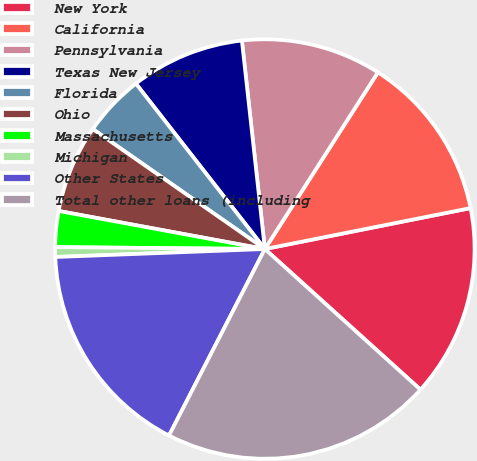<chart> <loc_0><loc_0><loc_500><loc_500><pie_chart><fcel>New York<fcel>California<fcel>Pennsylvania<fcel>Texas New Jersey<fcel>Florida<fcel>Ohio<fcel>Massachusetts<fcel>Michigan<fcel>Other States<fcel>Total other loans (including<nl><fcel>14.82%<fcel>12.81%<fcel>10.8%<fcel>8.79%<fcel>4.77%<fcel>6.78%<fcel>2.76%<fcel>0.75%<fcel>16.83%<fcel>20.85%<nl></chart> 